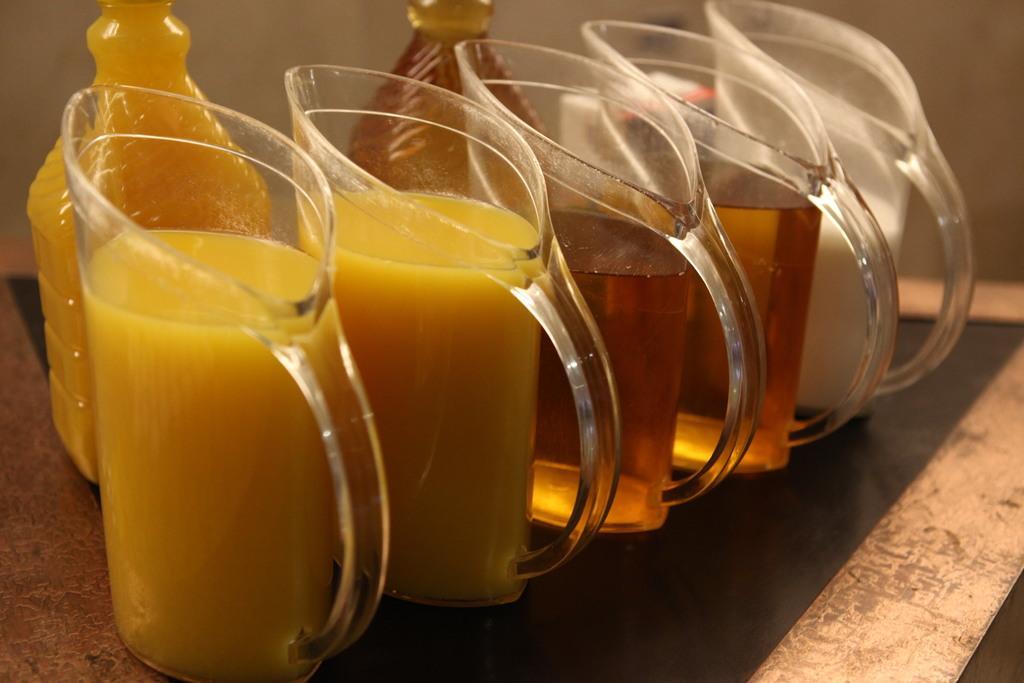How would you summarize this image in a sentence or two? In this image, I can see the jugs with the liquid items and two glass bottles, which are placed on a table. The background looks blurry. 